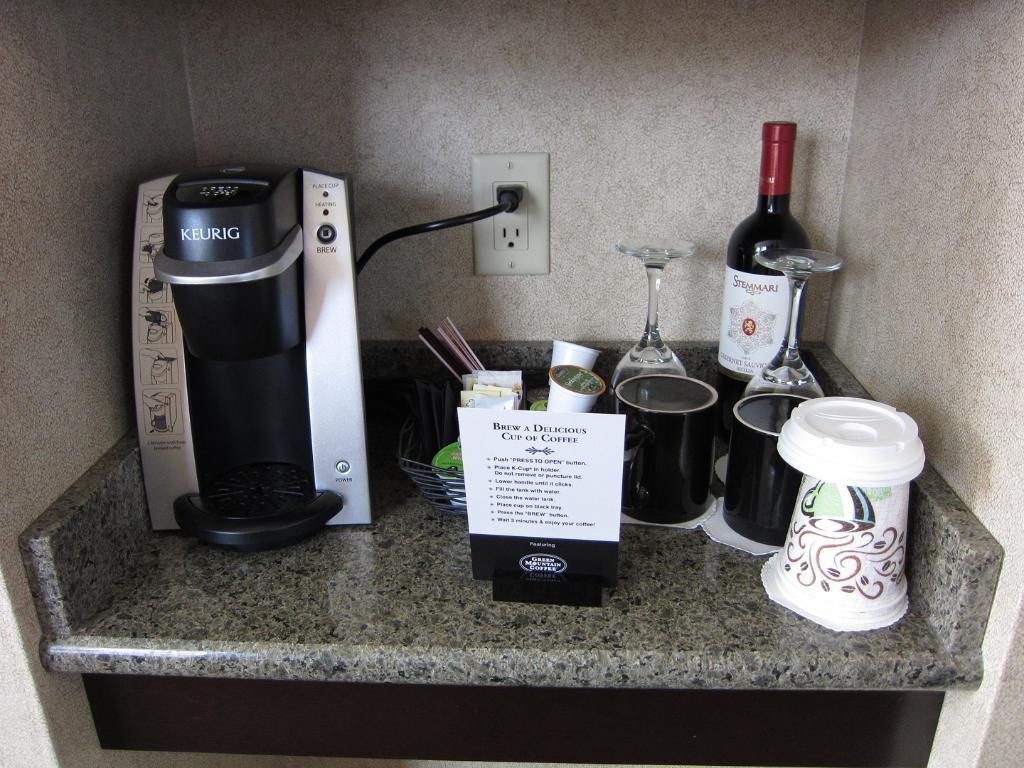<image>
Write a terse but informative summary of the picture. A sign invites you to "brew a delicious cup of coffee." 